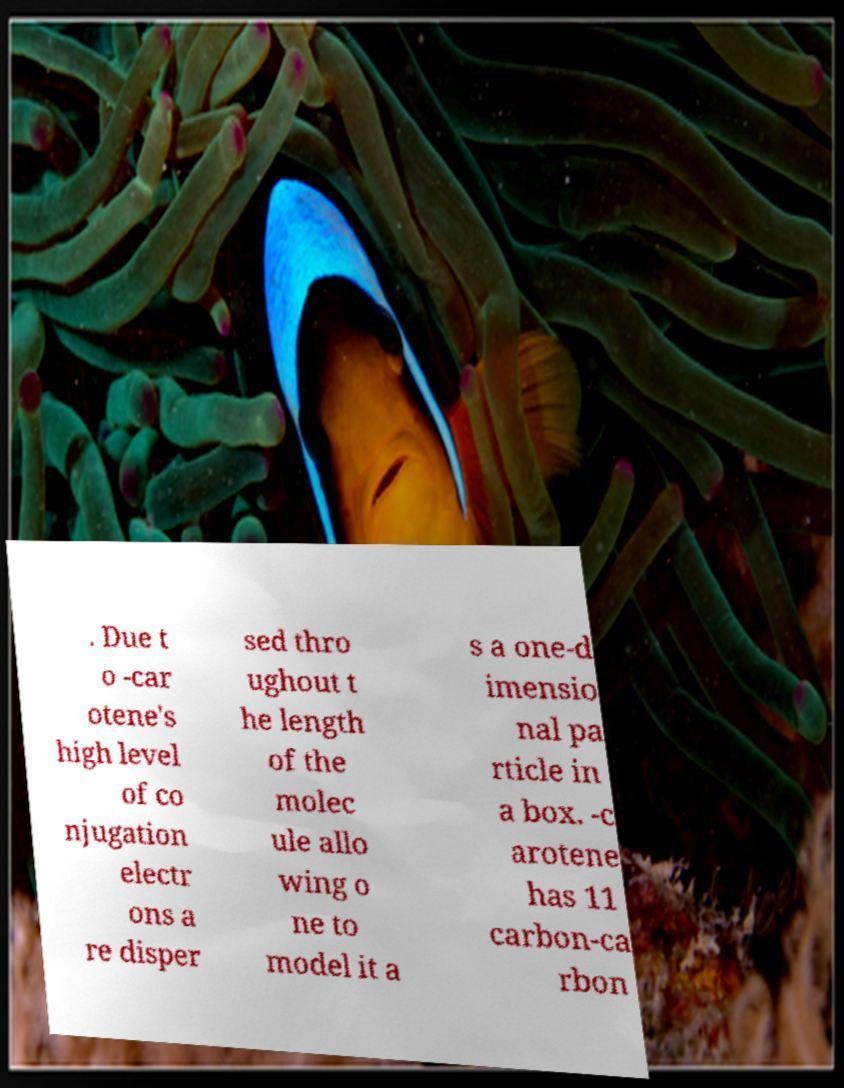For documentation purposes, I need the text within this image transcribed. Could you provide that? . Due t o -car otene's high level of co njugation electr ons a re disper sed thro ughout t he length of the molec ule allo wing o ne to model it a s a one-d imensio nal pa rticle in a box. -c arotene has 11 carbon-ca rbon 